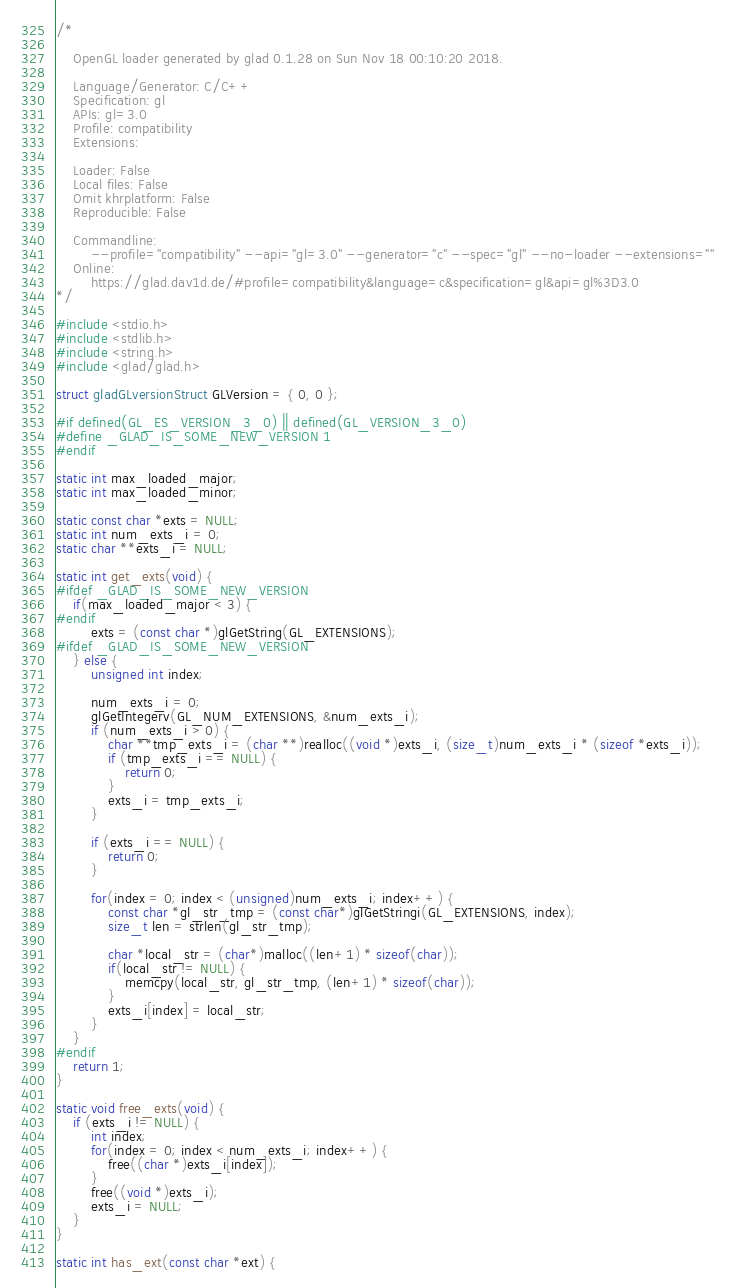<code> <loc_0><loc_0><loc_500><loc_500><_C_>/*

    OpenGL loader generated by glad 0.1.28 on Sun Nov 18 00:10:20 2018.

    Language/Generator: C/C++
    Specification: gl
    APIs: gl=3.0
    Profile: compatibility
    Extensions:
        
    Loader: False
    Local files: False
    Omit khrplatform: False
    Reproducible: False

    Commandline:
        --profile="compatibility" --api="gl=3.0" --generator="c" --spec="gl" --no-loader --extensions=""
    Online:
        https://glad.dav1d.de/#profile=compatibility&language=c&specification=gl&api=gl%3D3.0
*/

#include <stdio.h>
#include <stdlib.h>
#include <string.h>
#include <glad/glad.h>

struct gladGLversionStruct GLVersion = { 0, 0 };

#if defined(GL_ES_VERSION_3_0) || defined(GL_VERSION_3_0)
#define _GLAD_IS_SOME_NEW_VERSION 1
#endif

static int max_loaded_major;
static int max_loaded_minor;

static const char *exts = NULL;
static int num_exts_i = 0;
static char **exts_i = NULL;

static int get_exts(void) {
#ifdef _GLAD_IS_SOME_NEW_VERSION
    if(max_loaded_major < 3) {
#endif
        exts = (const char *)glGetString(GL_EXTENSIONS);
#ifdef _GLAD_IS_SOME_NEW_VERSION
    } else {
        unsigned int index;

        num_exts_i = 0;
        glGetIntegerv(GL_NUM_EXTENSIONS, &num_exts_i);
        if (num_exts_i > 0) {
            char **tmp_exts_i = (char **)realloc((void *)exts_i, (size_t)num_exts_i * (sizeof *exts_i));
            if (tmp_exts_i == NULL) {
                return 0;
            }
            exts_i = tmp_exts_i;
        }

        if (exts_i == NULL) {
            return 0;
        }

        for(index = 0; index < (unsigned)num_exts_i; index++) {
            const char *gl_str_tmp = (const char*)glGetStringi(GL_EXTENSIONS, index);
            size_t len = strlen(gl_str_tmp);

            char *local_str = (char*)malloc((len+1) * sizeof(char));
            if(local_str != NULL) {
                memcpy(local_str, gl_str_tmp, (len+1) * sizeof(char));
            }
            exts_i[index] = local_str;
        }
    }
#endif
    return 1;
}

static void free_exts(void) {
    if (exts_i != NULL) {
        int index;
        for(index = 0; index < num_exts_i; index++) {
            free((char *)exts_i[index]);
        }
        free((void *)exts_i);
        exts_i = NULL;
    }
}

static int has_ext(const char *ext) {</code> 